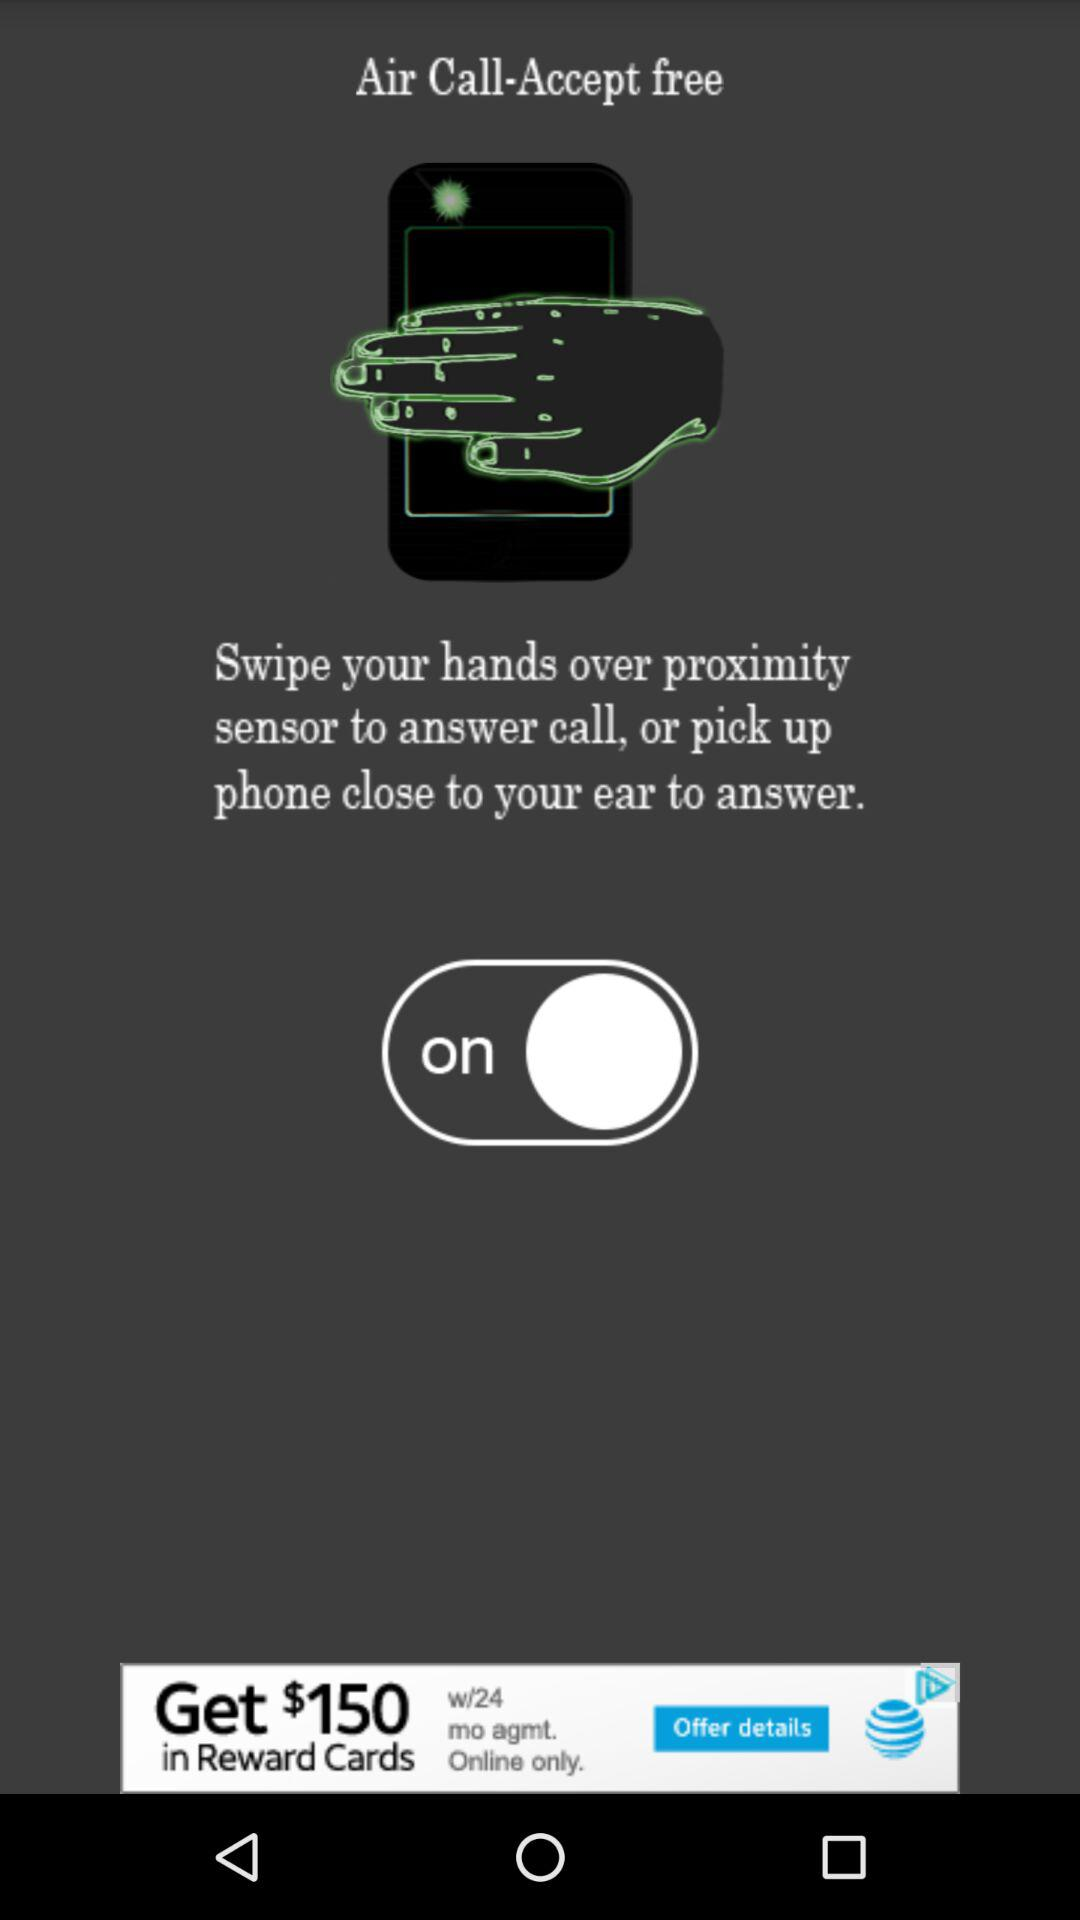What is the status of "Air Call-Accept free"? The status is "on". 